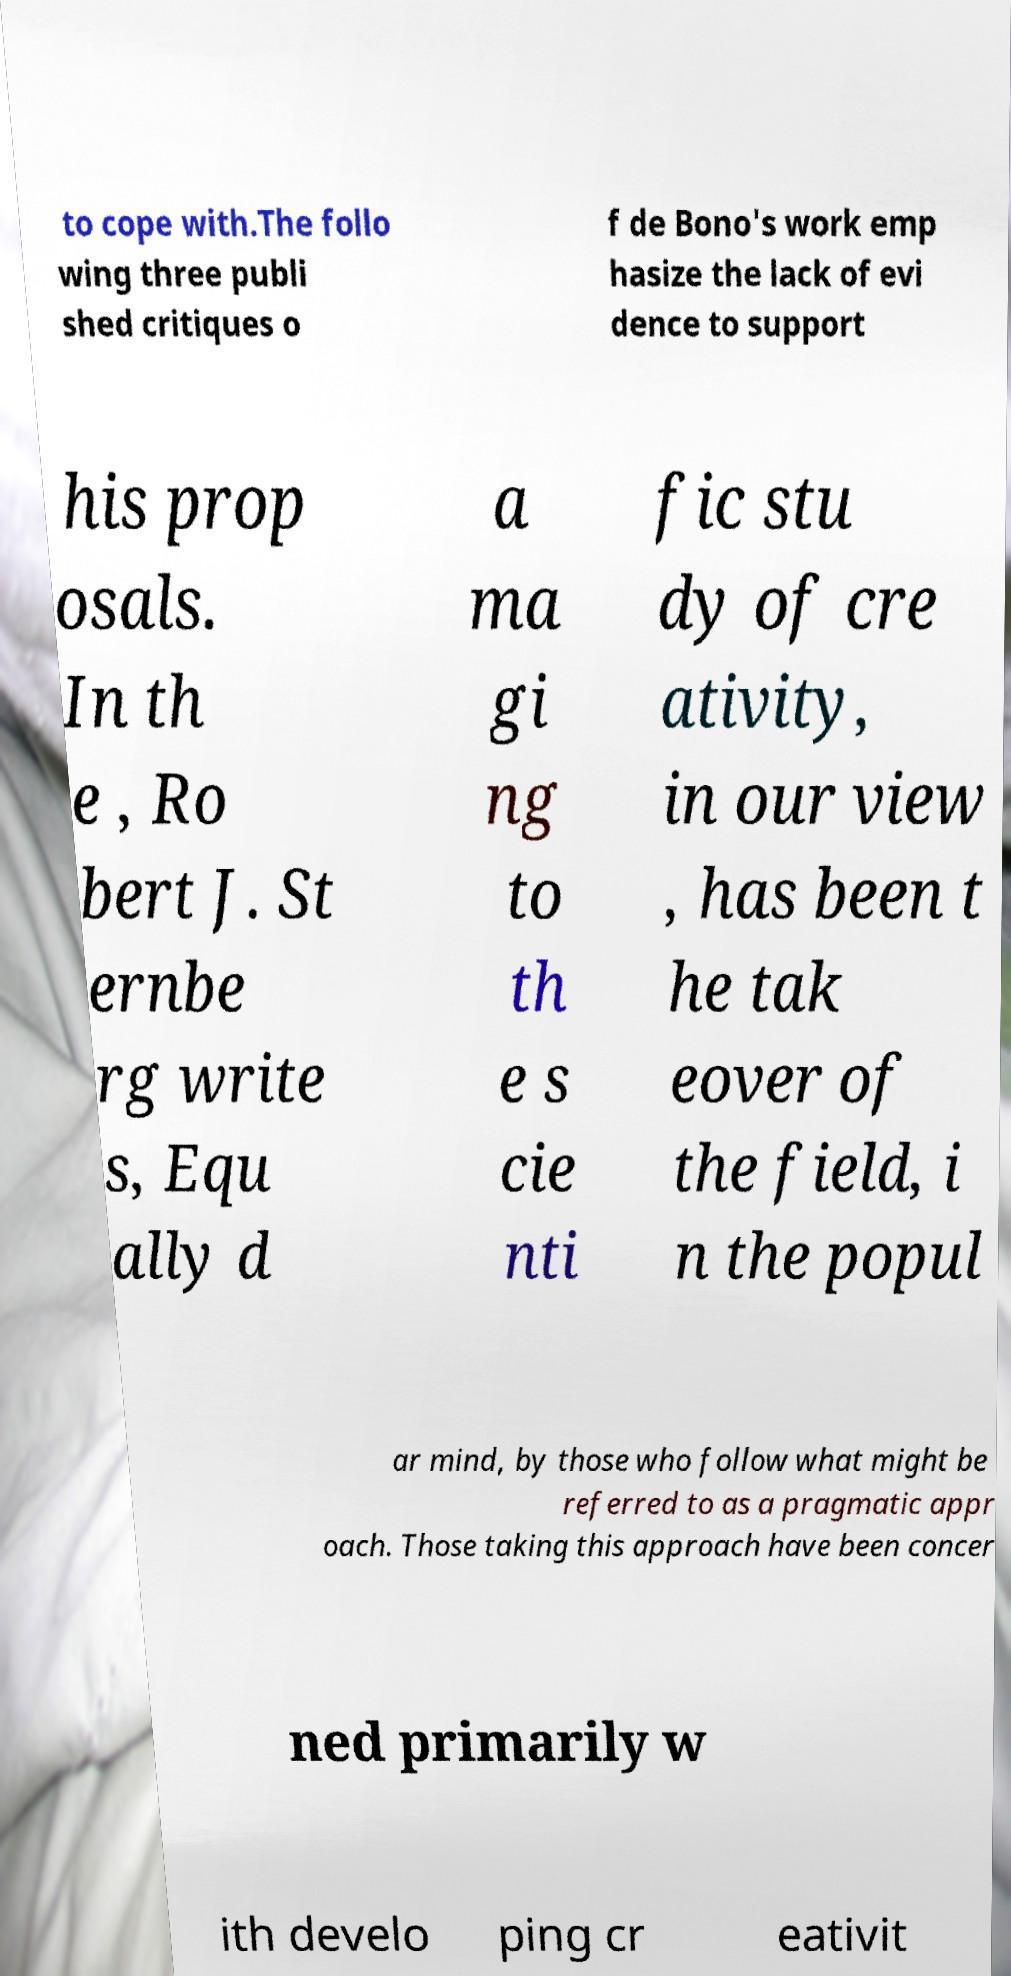Could you extract and type out the text from this image? to cope with.The follo wing three publi shed critiques o f de Bono's work emp hasize the lack of evi dence to support his prop osals. In th e , Ro bert J. St ernbe rg write s, Equ ally d a ma gi ng to th e s cie nti fic stu dy of cre ativity, in our view , has been t he tak eover of the field, i n the popul ar mind, by those who follow what might be referred to as a pragmatic appr oach. Those taking this approach have been concer ned primarily w ith develo ping cr eativit 